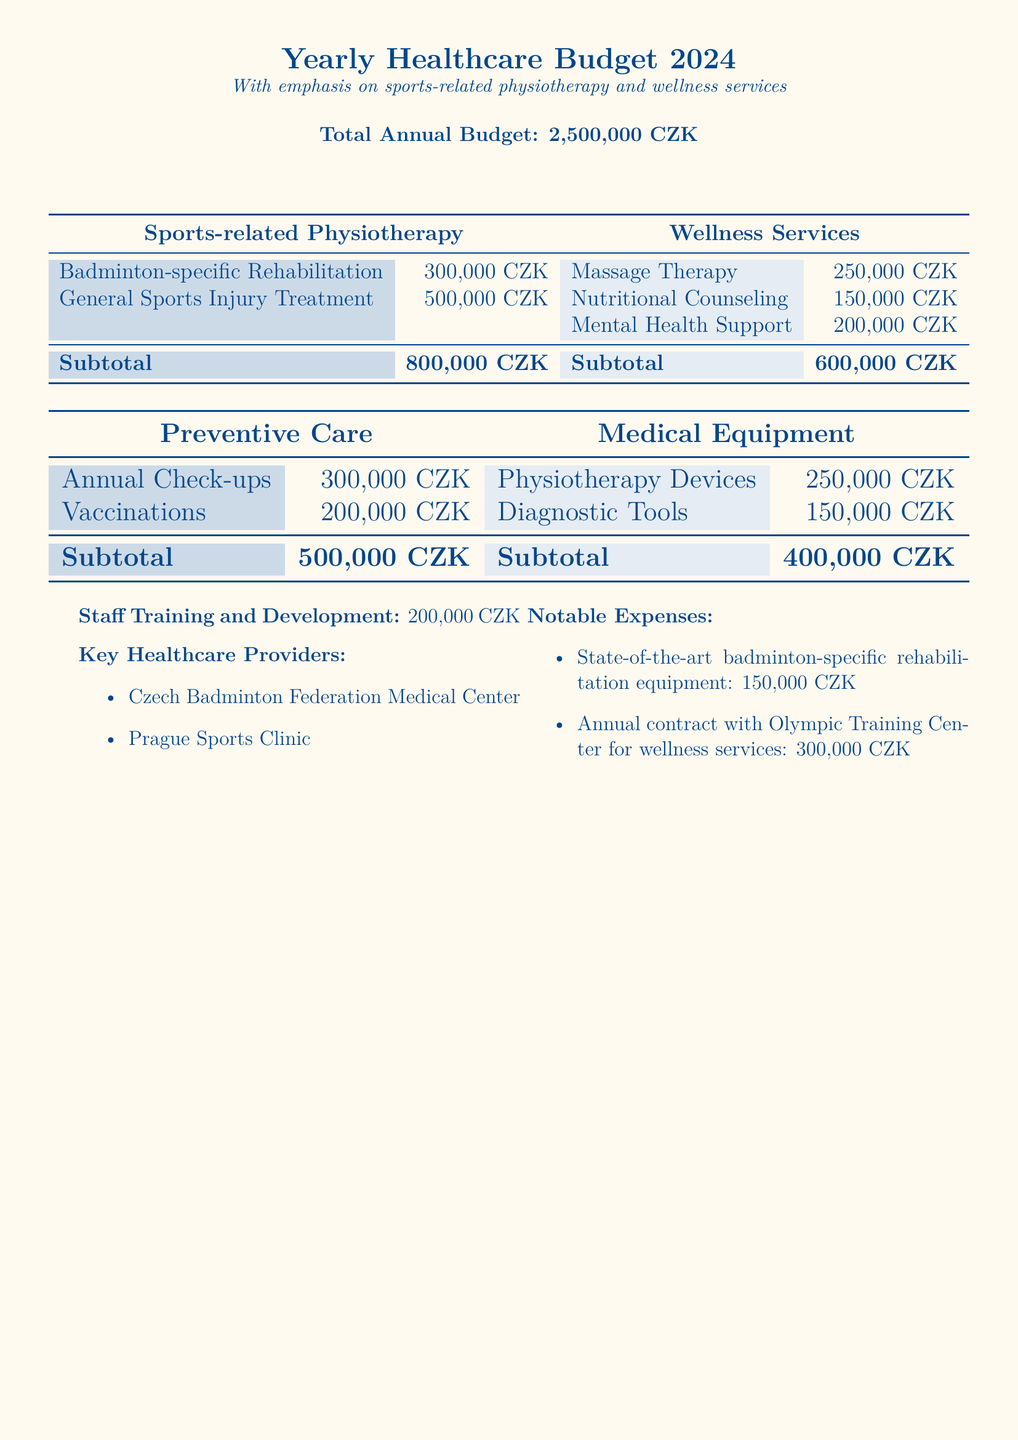What is the total annual budget? The total annual budget is stated at the beginning of the document.
Answer: 2,500,000 CZK How much is allocated for badminton-specific rehabilitation? The document lists the budget specifically for badminton-related rehabilitation.
Answer: 300,000 CZK What is the budget for wellness services? The total budget for wellness services is provided in the table section of the document.
Answer: 600,000 CZK What are the key healthcare providers mentioned? The document lists the healthcare providers in the key section.
Answer: Czech Badminton Federation Medical Center, Prague Sports Clinic What is the amount allocated for staff training and development? This amount is specified in the document as a separate line item.
Answer: 200,000 CZK How much is the annual contract with the Olympic Training Center? This expense is mentioned in the notable expenses section of the document.
Answer: 300,000 CZK What is the subtotal for medical equipment? The subtotal is calculated from the specific costs listed in the medical equipment section.
Answer: 400,000 CZK What type of mental health support is included in wellness services? The wellness services section lists all services offered, including mental health support.
Answer: Mental Health Support How much is budgeted for annual check-ups? The document provides a specific budget for annual check-ups under the preventive care section.
Answer: 300,000 CZK What is the total for sports-related physiotherapy? This total is the sum of all sports-related physiotherapy services listed in the document.
Answer: 800,000 CZK 